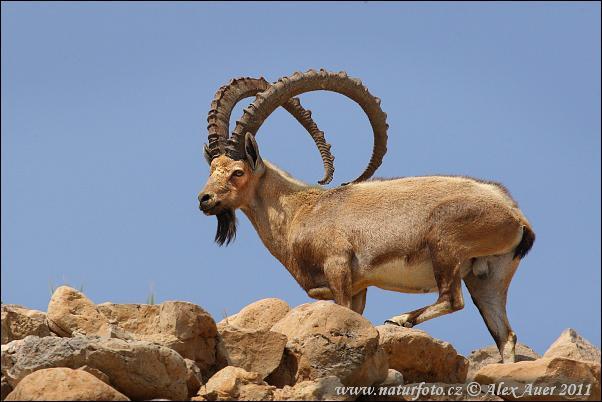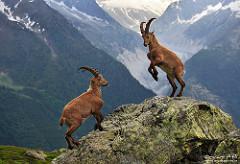The first image is the image on the left, the second image is the image on the right. For the images shown, is this caption "All images show at least two horned animals in some kind of face-off, and in one image at least one animal has its front legs off the ground." true? Answer yes or no. No. The first image is the image on the left, the second image is the image on the right. For the images displayed, is the sentence "There are three antelopes on a rocky mountain in the pair of images." factually correct? Answer yes or no. Yes. 